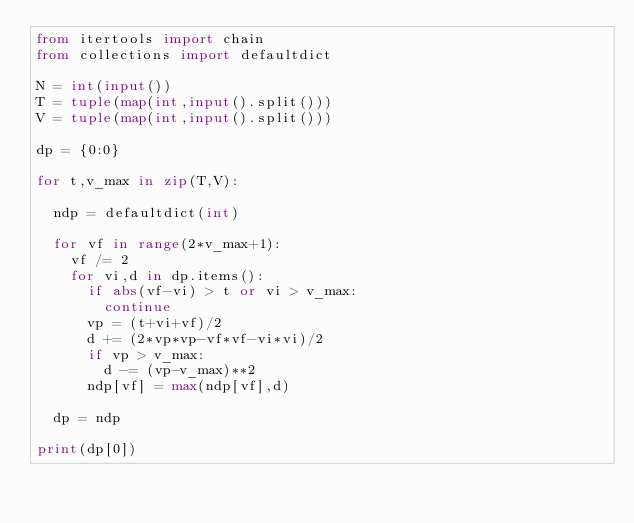Convert code to text. <code><loc_0><loc_0><loc_500><loc_500><_Python_>from itertools import chain
from collections import defaultdict

N = int(input())
T = tuple(map(int,input().split()))
V = tuple(map(int,input().split()))

dp = {0:0}

for t,v_max in zip(T,V):

  ndp = defaultdict(int)

  for vf in range(2*v_max+1):
    vf /= 2
    for vi,d in dp.items():
      if abs(vf-vi) > t or vi > v_max:
        continue
      vp = (t+vi+vf)/2
      d += (2*vp*vp-vf*vf-vi*vi)/2
      if vp > v_max:
        d -= (vp-v_max)**2
      ndp[vf] = max(ndp[vf],d)
  
  dp = ndp

print(dp[0])</code> 